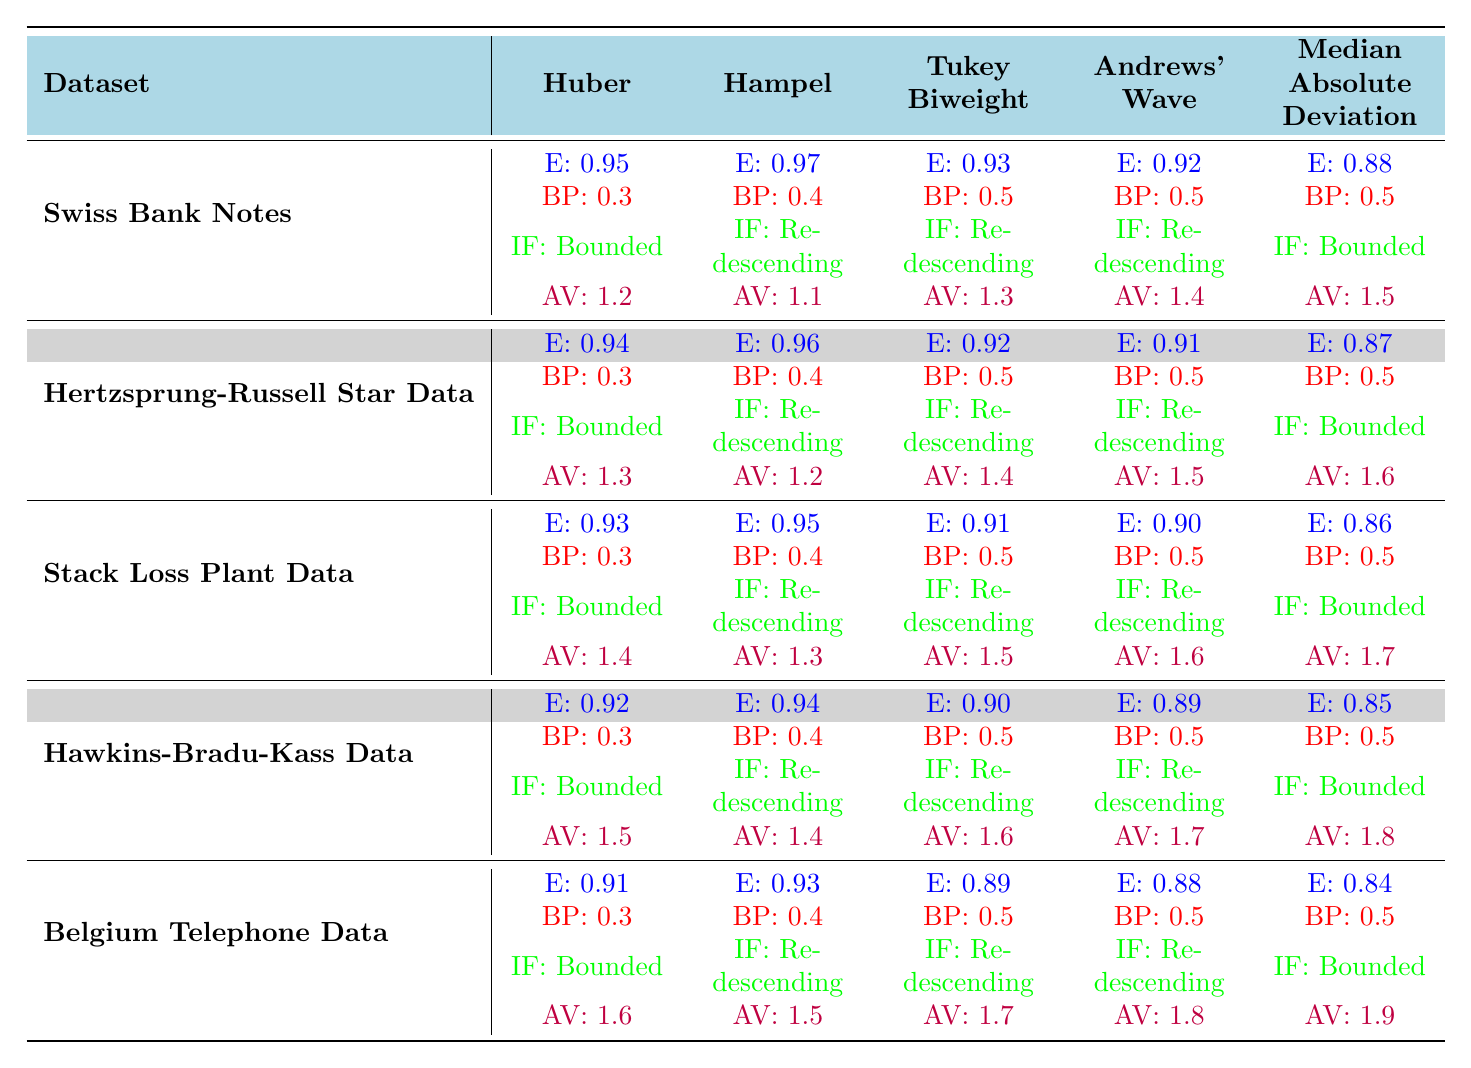What is the efficiency of the Huber M-estimator for the Swiss Bank Notes dataset? According to the table, the efficiency of the Huber M-estimator for the Swiss Bank Notes dataset is given as 0.95 in the corresponding cell.
Answer: 0.95 What is the breakdown point of the Hampel M-estimator for the Stack Loss Plant Data? The table shows that the breakdown point (BP) for the Hampel M-estimator in the Stack Loss Plant Data is 0.4, located in the relevant row and column.
Answer: 0.4 Which M-estimator has the highest efficiency for the Hertzsprung-Russell Star Data? Looking at the efficiencies listed for the M-estimators under the Hertzsprung-Russell Star Data, the Hampel M-estimator has the highest efficiency at 0.96.
Answer: Hampel Is the influence function of the Median Absolute Deviation for the Belgium Telephone Data bounded? The table indicates that the influence function for the Median Absolute Deviation in the Belgium Telephone Data is labeled as "Bounded," confirming the fact.
Answer: Yes What is the average efficiency of all M-estimators for the Hawkins-Bradu-Kass Data? Adding the efficiencies: 0.92 (Huber) + 0.94 (Hampel) + 0.90 (Tukey Biweight) + 0.89 (Andrews' Wave) + 0.85 (Median Absolute Deviation) = 4.50. Dividing by 5 gives an average efficiency of 4.50 / 5 = 0.90.
Answer: 0.90 Which M-estimator has the lowest breakdown point across all datasets? By comparing the breakdown points of all M-estimators from the table, it's noticed that all the breakdown points are at least 0.3, but the lowest is 0.3, which is found for the Huber estimator across multiple datasets, confirming it's the lowest.
Answer: Huber What is the influence function of the Tukey Biweight M-estimator for the Swiss Bank Notes dataset? In the table, the influence function for the Tukey Biweight M-estimator is classified as "Redescending" in the Swiss Bank Notes dataset.
Answer: Redescending What is the asymptotic variance of the Median Absolute Deviation for the Stack Loss Plant Data? According to the table, the asymptotic variance for the Median Absolute Deviation in the Stack Loss Plant Data is given as 1.7.
Answer: 1.7 Which dataset shows the highest efficiency for the Huber M-estimator, and what is that efficiency? The efficiencies of the Huber M-estimator across datasets are 0.95 (Swiss Bank Notes), 0.94 (Hertzsprung-Russell), 0.93 (Stack Loss Plant), 0.92 (Hawkins-Bradu-Kass), and 0.91 (Belgium Telephone). The highest efficiency is 0.95 for Swiss Bank Notes.
Answer: Swiss Bank Notes, 0.95 If you want to maximize the breakdown point, which M-estimator should you choose based on Stack Loss Plant Data? In the Stack Loss Plant Data, the Hampel M-estimator has the highest breakdown point of 0.4 compared to others, indicating that it would be the best choice for maximizing the breakdown point in this dataset.
Answer: Hampel 